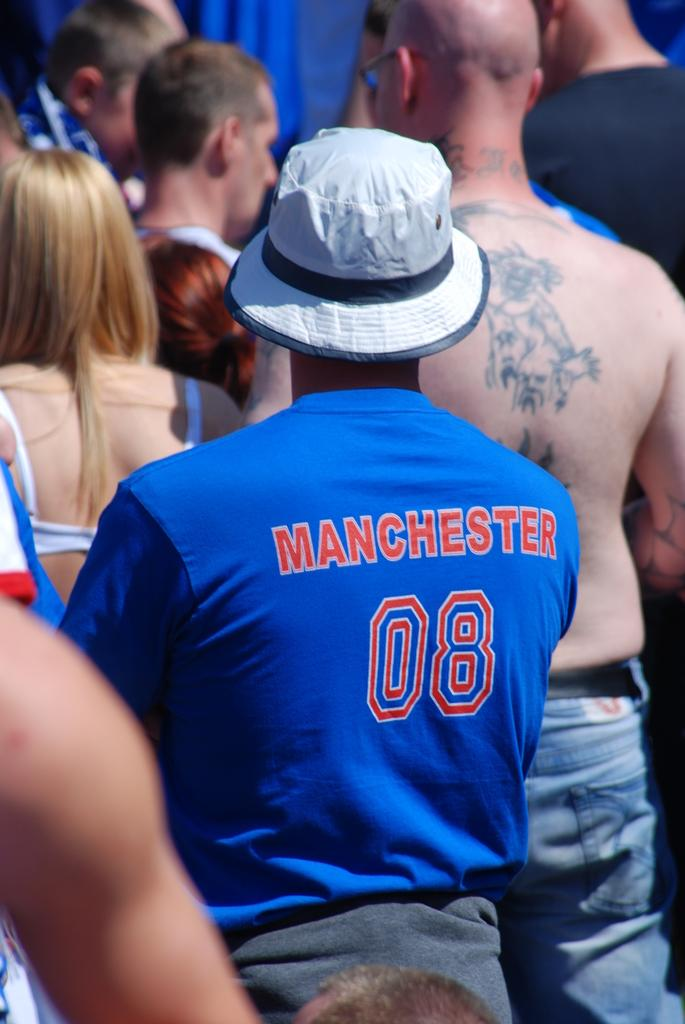Provide a one-sentence caption for the provided image. the backs of some people standing, the shirt says MANCHESTER 08 and another man's bare back has tattoos on it. 